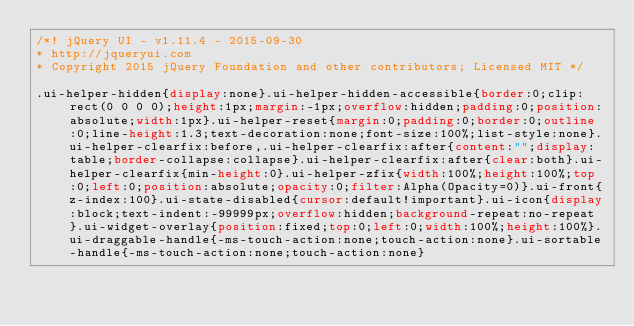<code> <loc_0><loc_0><loc_500><loc_500><_CSS_>/*! jQuery UI - v1.11.4 - 2015-09-30
* http://jqueryui.com
* Copyright 2015 jQuery Foundation and other contributors; Licensed MIT */

.ui-helper-hidden{display:none}.ui-helper-hidden-accessible{border:0;clip:rect(0 0 0 0);height:1px;margin:-1px;overflow:hidden;padding:0;position:absolute;width:1px}.ui-helper-reset{margin:0;padding:0;border:0;outline:0;line-height:1.3;text-decoration:none;font-size:100%;list-style:none}.ui-helper-clearfix:before,.ui-helper-clearfix:after{content:"";display:table;border-collapse:collapse}.ui-helper-clearfix:after{clear:both}.ui-helper-clearfix{min-height:0}.ui-helper-zfix{width:100%;height:100%;top:0;left:0;position:absolute;opacity:0;filter:Alpha(Opacity=0)}.ui-front{z-index:100}.ui-state-disabled{cursor:default!important}.ui-icon{display:block;text-indent:-99999px;overflow:hidden;background-repeat:no-repeat}.ui-widget-overlay{position:fixed;top:0;left:0;width:100%;height:100%}.ui-draggable-handle{-ms-touch-action:none;touch-action:none}.ui-sortable-handle{-ms-touch-action:none;touch-action:none}</code> 